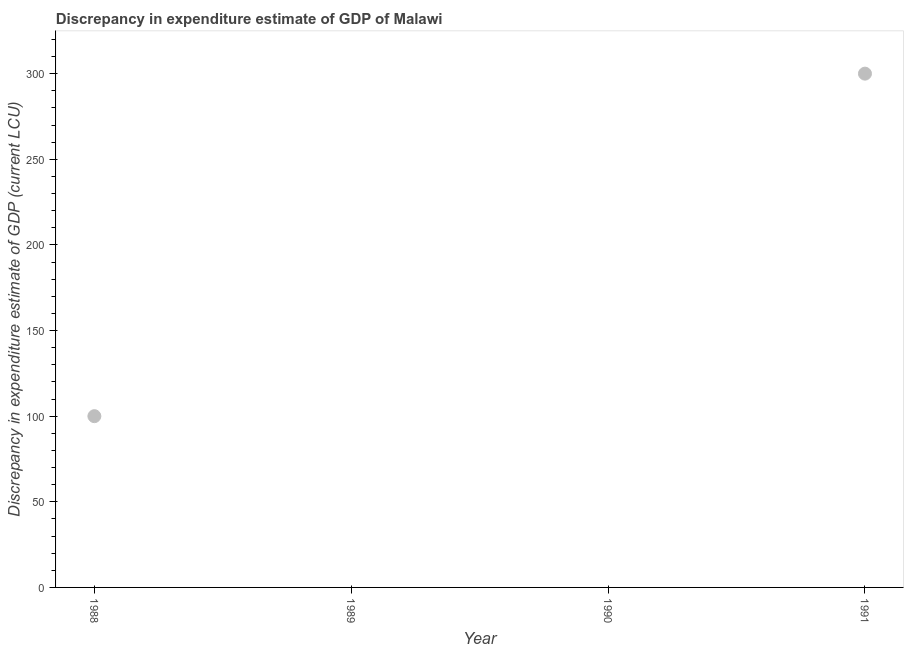Across all years, what is the maximum discrepancy in expenditure estimate of gdp?
Offer a terse response. 300. In which year was the discrepancy in expenditure estimate of gdp maximum?
Your response must be concise. 1991. What is the sum of the discrepancy in expenditure estimate of gdp?
Your answer should be compact. 400. In how many years, is the discrepancy in expenditure estimate of gdp greater than 30 LCU?
Your response must be concise. 2. What is the ratio of the discrepancy in expenditure estimate of gdp in 1988 to that in 1991?
Your answer should be compact. 0.33. Is the sum of the discrepancy in expenditure estimate of gdp in 1988 and 1991 greater than the maximum discrepancy in expenditure estimate of gdp across all years?
Provide a succinct answer. Yes. What is the difference between the highest and the lowest discrepancy in expenditure estimate of gdp?
Ensure brevity in your answer.  300. In how many years, is the discrepancy in expenditure estimate of gdp greater than the average discrepancy in expenditure estimate of gdp taken over all years?
Your answer should be compact. 1. How many dotlines are there?
Keep it short and to the point. 1. How many years are there in the graph?
Keep it short and to the point. 4. Are the values on the major ticks of Y-axis written in scientific E-notation?
Offer a very short reply. No. What is the title of the graph?
Offer a very short reply. Discrepancy in expenditure estimate of GDP of Malawi. What is the label or title of the Y-axis?
Your answer should be very brief. Discrepancy in expenditure estimate of GDP (current LCU). What is the Discrepancy in expenditure estimate of GDP (current LCU) in 1988?
Give a very brief answer. 100. What is the Discrepancy in expenditure estimate of GDP (current LCU) in 1989?
Provide a short and direct response. 0. What is the Discrepancy in expenditure estimate of GDP (current LCU) in 1991?
Ensure brevity in your answer.  300. What is the difference between the Discrepancy in expenditure estimate of GDP (current LCU) in 1988 and 1991?
Provide a succinct answer. -200. What is the ratio of the Discrepancy in expenditure estimate of GDP (current LCU) in 1988 to that in 1991?
Give a very brief answer. 0.33. 